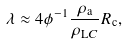<formula> <loc_0><loc_0><loc_500><loc_500>\lambda \approx 4 \phi ^ { - 1 } \frac { \rho _ { \text {a} } } { \rho _ { \text  LC}} R_{\text {c}},</formula> 